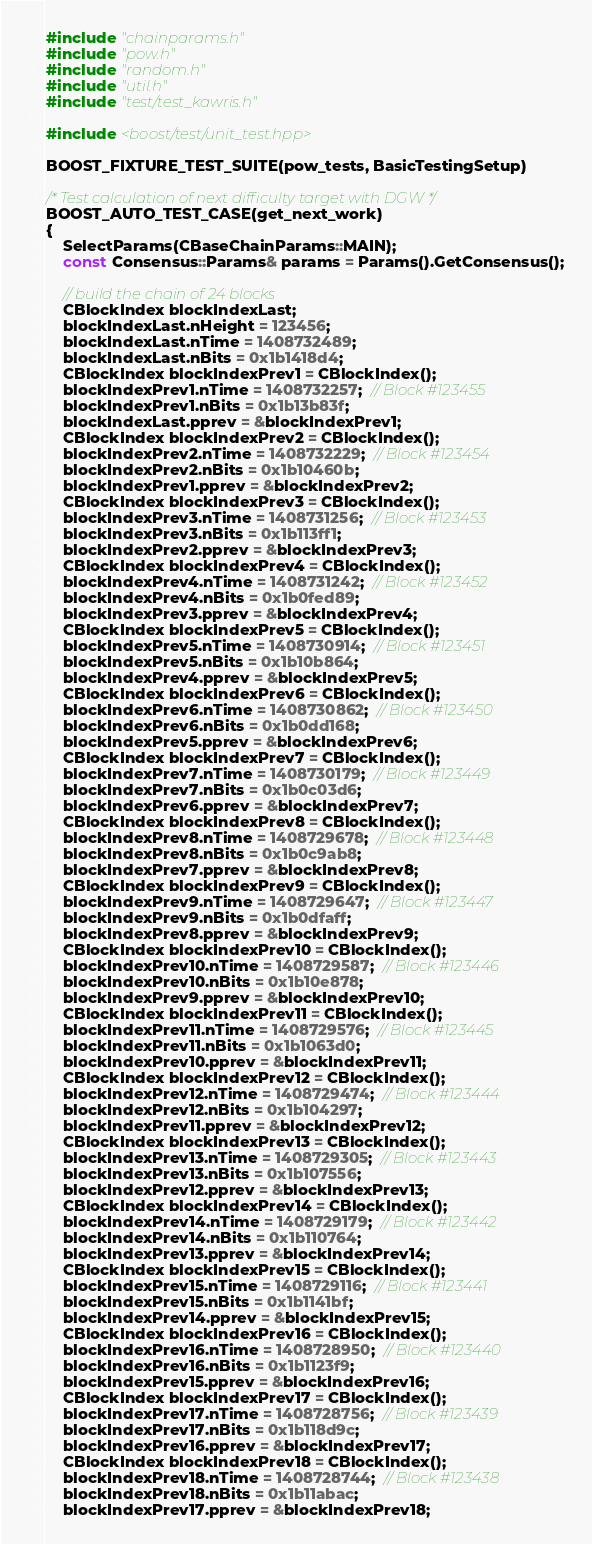<code> <loc_0><loc_0><loc_500><loc_500><_C++_>#include "chainparams.h"
#include "pow.h"
#include "random.h"
#include "util.h"
#include "test/test_kawris.h"

#include <boost/test/unit_test.hpp>

BOOST_FIXTURE_TEST_SUITE(pow_tests, BasicTestingSetup)

/* Test calculation of next difficulty target with DGW */
BOOST_AUTO_TEST_CASE(get_next_work)
{
    SelectParams(CBaseChainParams::MAIN);
    const Consensus::Params& params = Params().GetConsensus();

    // build the chain of 24 blocks
    CBlockIndex blockIndexLast;
    blockIndexLast.nHeight = 123456;
    blockIndexLast.nTime = 1408732489;
    blockIndexLast.nBits = 0x1b1418d4;
    CBlockIndex blockIndexPrev1 = CBlockIndex();
    blockIndexPrev1.nTime = 1408732257;  // Block #123455
    blockIndexPrev1.nBits = 0x1b13b83f;
    blockIndexLast.pprev = &blockIndexPrev1;
    CBlockIndex blockIndexPrev2 = CBlockIndex();
    blockIndexPrev2.nTime = 1408732229;  // Block #123454
    blockIndexPrev2.nBits = 0x1b10460b;
    blockIndexPrev1.pprev = &blockIndexPrev2;
    CBlockIndex blockIndexPrev3 = CBlockIndex();
    blockIndexPrev3.nTime = 1408731256;  // Block #123453
    blockIndexPrev3.nBits = 0x1b113ff1;
    blockIndexPrev2.pprev = &blockIndexPrev3;
    CBlockIndex blockIndexPrev4 = CBlockIndex();
    blockIndexPrev4.nTime = 1408731242;  // Block #123452
    blockIndexPrev4.nBits = 0x1b0fed89;
    blockIndexPrev3.pprev = &blockIndexPrev4;
    CBlockIndex blockIndexPrev5 = CBlockIndex();
    blockIndexPrev5.nTime = 1408730914;  // Block #123451
    blockIndexPrev5.nBits = 0x1b10b864;
    blockIndexPrev4.pprev = &blockIndexPrev5;
    CBlockIndex blockIndexPrev6 = CBlockIndex();
    blockIndexPrev6.nTime = 1408730862;  // Block #123450
    blockIndexPrev6.nBits = 0x1b0dd168;
    blockIndexPrev5.pprev = &blockIndexPrev6;
    CBlockIndex blockIndexPrev7 = CBlockIndex();
    blockIndexPrev7.nTime = 1408730179;  // Block #123449
    blockIndexPrev7.nBits = 0x1b0c03d6;
    blockIndexPrev6.pprev = &blockIndexPrev7;
    CBlockIndex blockIndexPrev8 = CBlockIndex();
    blockIndexPrev8.nTime = 1408729678;  // Block #123448
    blockIndexPrev8.nBits = 0x1b0c9ab8;
    blockIndexPrev7.pprev = &blockIndexPrev8;
    CBlockIndex blockIndexPrev9 = CBlockIndex();
    blockIndexPrev9.nTime = 1408729647;  // Block #123447
    blockIndexPrev9.nBits = 0x1b0dfaff;
    blockIndexPrev8.pprev = &blockIndexPrev9;
    CBlockIndex blockIndexPrev10 = CBlockIndex();
    blockIndexPrev10.nTime = 1408729587;  // Block #123446
    blockIndexPrev10.nBits = 0x1b10e878;
    blockIndexPrev9.pprev = &blockIndexPrev10;
    CBlockIndex blockIndexPrev11 = CBlockIndex();
    blockIndexPrev11.nTime = 1408729576;  // Block #123445
    blockIndexPrev11.nBits = 0x1b1063d0;
    blockIndexPrev10.pprev = &blockIndexPrev11;
    CBlockIndex blockIndexPrev12 = CBlockIndex();
    blockIndexPrev12.nTime = 1408729474;  // Block #123444
    blockIndexPrev12.nBits = 0x1b104297;
    blockIndexPrev11.pprev = &blockIndexPrev12;
    CBlockIndex blockIndexPrev13 = CBlockIndex();
    blockIndexPrev13.nTime = 1408729305;  // Block #123443
    blockIndexPrev13.nBits = 0x1b107556;
    blockIndexPrev12.pprev = &blockIndexPrev13;
    CBlockIndex blockIndexPrev14 = CBlockIndex();
    blockIndexPrev14.nTime = 1408729179;  // Block #123442
    blockIndexPrev14.nBits = 0x1b110764;
    blockIndexPrev13.pprev = &blockIndexPrev14;
    CBlockIndex blockIndexPrev15 = CBlockIndex();
    blockIndexPrev15.nTime = 1408729116;  // Block #123441
    blockIndexPrev15.nBits = 0x1b1141bf;
    blockIndexPrev14.pprev = &blockIndexPrev15;
    CBlockIndex blockIndexPrev16 = CBlockIndex();
    blockIndexPrev16.nTime = 1408728950;  // Block #123440
    blockIndexPrev16.nBits = 0x1b1123f9;
    blockIndexPrev15.pprev = &blockIndexPrev16;
    CBlockIndex blockIndexPrev17 = CBlockIndex();
    blockIndexPrev17.nTime = 1408728756;  // Block #123439
    blockIndexPrev17.nBits = 0x1b118d9c;
    blockIndexPrev16.pprev = &blockIndexPrev17;
    CBlockIndex blockIndexPrev18 = CBlockIndex();
    blockIndexPrev18.nTime = 1408728744;  // Block #123438
    blockIndexPrev18.nBits = 0x1b11abac;
    blockIndexPrev17.pprev = &blockIndexPrev18;</code> 